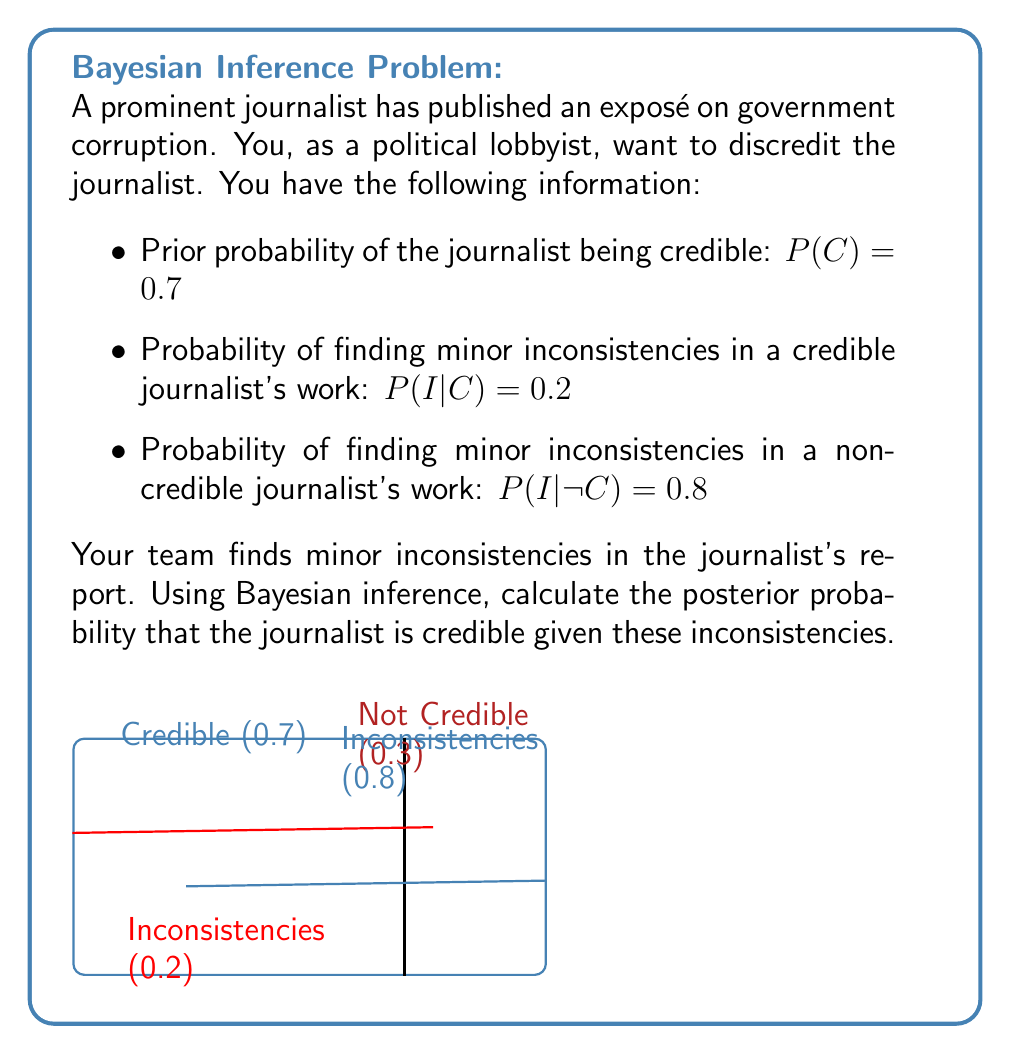What is the answer to this math problem? Let's solve this step-by-step using Bayes' theorem:

1) We want to find $P(C|I)$, the probability that the journalist is credible given the inconsistencies.

2) Bayes' theorem states:

   $$P(C|I) = \frac{P(I|C) \cdot P(C)}{P(I)}$$

3) We know $P(I|C) = 0.2$ and $P(C) = 0.7$. We need to calculate $P(I)$.

4) We can calculate $P(I)$ using the law of total probability:

   $$P(I) = P(I|C) \cdot P(C) + P(I|\neg C) \cdot P(\neg C)$$

5) We know $P(\neg C) = 1 - P(C) = 1 - 0.7 = 0.3$

6) Substituting the values:

   $$P(I) = 0.2 \cdot 0.7 + 0.8 \cdot 0.3 = 0.14 + 0.24 = 0.38$$

7) Now we can apply Bayes' theorem:

   $$P(C|I) = \frac{0.2 \cdot 0.7}{0.38} = \frac{0.14}{0.38} \approx 0.3684$$

8) Converting to a percentage: $0.3684 \cdot 100\% \approx 36.84\%$
Answer: $36.84\%$ 